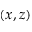Convert formula to latex. <formula><loc_0><loc_0><loc_500><loc_500>( x , z )</formula> 